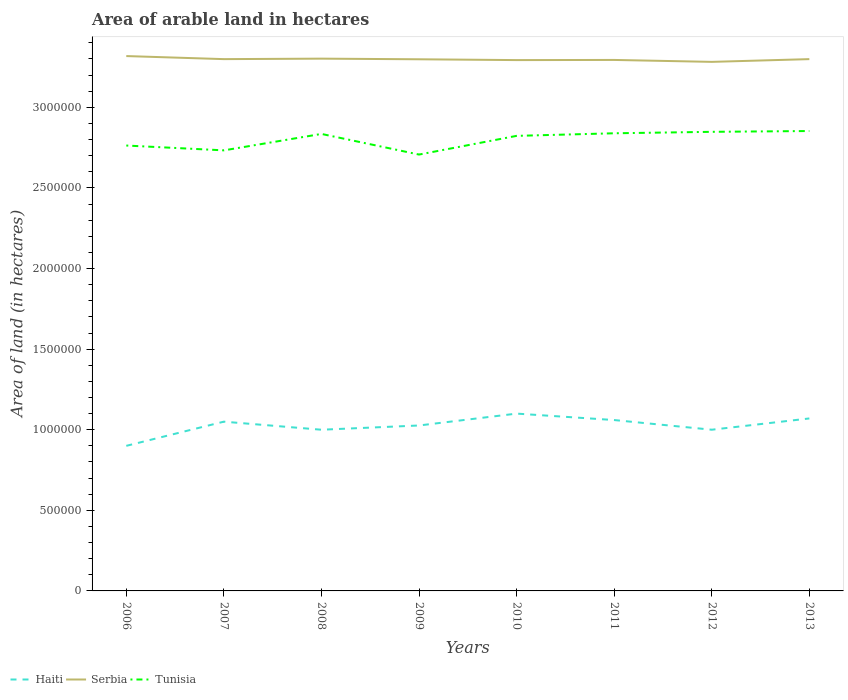Is the number of lines equal to the number of legend labels?
Offer a very short reply. Yes. Across all years, what is the maximum total arable land in Haiti?
Offer a very short reply. 9.00e+05. In which year was the total arable land in Haiti maximum?
Ensure brevity in your answer.  2006. What is the total total arable land in Serbia in the graph?
Keep it short and to the point. 1.10e+04. What is the difference between the highest and the second highest total arable land in Serbia?
Provide a succinct answer. 3.60e+04. Is the total arable land in Serbia strictly greater than the total arable land in Haiti over the years?
Make the answer very short. No. How many lines are there?
Give a very brief answer. 3. Are the values on the major ticks of Y-axis written in scientific E-notation?
Keep it short and to the point. No. Does the graph contain any zero values?
Your answer should be compact. No. How many legend labels are there?
Offer a terse response. 3. What is the title of the graph?
Your response must be concise. Area of arable land in hectares. What is the label or title of the Y-axis?
Offer a very short reply. Area of land (in hectares). What is the Area of land (in hectares) of Serbia in 2006?
Keep it short and to the point. 3.32e+06. What is the Area of land (in hectares) of Tunisia in 2006?
Provide a short and direct response. 2.76e+06. What is the Area of land (in hectares) of Haiti in 2007?
Ensure brevity in your answer.  1.05e+06. What is the Area of land (in hectares) of Serbia in 2007?
Give a very brief answer. 3.30e+06. What is the Area of land (in hectares) in Tunisia in 2007?
Ensure brevity in your answer.  2.73e+06. What is the Area of land (in hectares) in Serbia in 2008?
Keep it short and to the point. 3.30e+06. What is the Area of land (in hectares) in Tunisia in 2008?
Keep it short and to the point. 2.84e+06. What is the Area of land (in hectares) of Haiti in 2009?
Make the answer very short. 1.03e+06. What is the Area of land (in hectares) in Serbia in 2009?
Provide a succinct answer. 3.30e+06. What is the Area of land (in hectares) of Tunisia in 2009?
Your response must be concise. 2.71e+06. What is the Area of land (in hectares) in Haiti in 2010?
Keep it short and to the point. 1.10e+06. What is the Area of land (in hectares) in Serbia in 2010?
Your answer should be compact. 3.29e+06. What is the Area of land (in hectares) of Tunisia in 2010?
Ensure brevity in your answer.  2.82e+06. What is the Area of land (in hectares) in Haiti in 2011?
Offer a terse response. 1.06e+06. What is the Area of land (in hectares) in Serbia in 2011?
Your answer should be very brief. 3.29e+06. What is the Area of land (in hectares) in Tunisia in 2011?
Keep it short and to the point. 2.84e+06. What is the Area of land (in hectares) in Serbia in 2012?
Your answer should be compact. 3.28e+06. What is the Area of land (in hectares) of Tunisia in 2012?
Provide a succinct answer. 2.85e+06. What is the Area of land (in hectares) in Haiti in 2013?
Your response must be concise. 1.07e+06. What is the Area of land (in hectares) of Serbia in 2013?
Give a very brief answer. 3.30e+06. What is the Area of land (in hectares) in Tunisia in 2013?
Make the answer very short. 2.85e+06. Across all years, what is the maximum Area of land (in hectares) in Haiti?
Provide a short and direct response. 1.10e+06. Across all years, what is the maximum Area of land (in hectares) in Serbia?
Your answer should be very brief. 3.32e+06. Across all years, what is the maximum Area of land (in hectares) in Tunisia?
Offer a terse response. 2.85e+06. Across all years, what is the minimum Area of land (in hectares) in Haiti?
Your answer should be compact. 9.00e+05. Across all years, what is the minimum Area of land (in hectares) of Serbia?
Offer a terse response. 3.28e+06. Across all years, what is the minimum Area of land (in hectares) in Tunisia?
Provide a succinct answer. 2.71e+06. What is the total Area of land (in hectares) in Haiti in the graph?
Your response must be concise. 8.21e+06. What is the total Area of land (in hectares) of Serbia in the graph?
Provide a succinct answer. 2.64e+07. What is the total Area of land (in hectares) in Tunisia in the graph?
Ensure brevity in your answer.  2.24e+07. What is the difference between the Area of land (in hectares) of Haiti in 2006 and that in 2007?
Provide a short and direct response. -1.50e+05. What is the difference between the Area of land (in hectares) of Serbia in 2006 and that in 2007?
Your answer should be compact. 1.90e+04. What is the difference between the Area of land (in hectares) of Tunisia in 2006 and that in 2007?
Make the answer very short. 3.00e+04. What is the difference between the Area of land (in hectares) in Haiti in 2006 and that in 2008?
Keep it short and to the point. -1.00e+05. What is the difference between the Area of land (in hectares) of Serbia in 2006 and that in 2008?
Give a very brief answer. 1.60e+04. What is the difference between the Area of land (in hectares) of Tunisia in 2006 and that in 2008?
Provide a succinct answer. -7.20e+04. What is the difference between the Area of land (in hectares) of Haiti in 2006 and that in 2009?
Provide a succinct answer. -1.26e+05. What is the difference between the Area of land (in hectares) in Serbia in 2006 and that in 2009?
Offer a very short reply. 2.00e+04. What is the difference between the Area of land (in hectares) in Tunisia in 2006 and that in 2009?
Provide a short and direct response. 5.60e+04. What is the difference between the Area of land (in hectares) of Serbia in 2006 and that in 2010?
Offer a very short reply. 2.50e+04. What is the difference between the Area of land (in hectares) in Haiti in 2006 and that in 2011?
Provide a succinct answer. -1.60e+05. What is the difference between the Area of land (in hectares) in Serbia in 2006 and that in 2011?
Provide a succinct answer. 2.40e+04. What is the difference between the Area of land (in hectares) of Tunisia in 2006 and that in 2011?
Your response must be concise. -7.60e+04. What is the difference between the Area of land (in hectares) in Serbia in 2006 and that in 2012?
Your answer should be very brief. 3.60e+04. What is the difference between the Area of land (in hectares) in Tunisia in 2006 and that in 2012?
Your answer should be compact. -8.50e+04. What is the difference between the Area of land (in hectares) of Serbia in 2006 and that in 2013?
Make the answer very short. 1.90e+04. What is the difference between the Area of land (in hectares) in Haiti in 2007 and that in 2008?
Offer a very short reply. 5.00e+04. What is the difference between the Area of land (in hectares) of Serbia in 2007 and that in 2008?
Offer a very short reply. -3000. What is the difference between the Area of land (in hectares) in Tunisia in 2007 and that in 2008?
Give a very brief answer. -1.02e+05. What is the difference between the Area of land (in hectares) of Haiti in 2007 and that in 2009?
Offer a very short reply. 2.37e+04. What is the difference between the Area of land (in hectares) in Serbia in 2007 and that in 2009?
Your answer should be compact. 1000. What is the difference between the Area of land (in hectares) of Tunisia in 2007 and that in 2009?
Make the answer very short. 2.60e+04. What is the difference between the Area of land (in hectares) of Serbia in 2007 and that in 2010?
Keep it short and to the point. 6000. What is the difference between the Area of land (in hectares) of Haiti in 2007 and that in 2011?
Give a very brief answer. -10000. What is the difference between the Area of land (in hectares) in Tunisia in 2007 and that in 2011?
Your answer should be compact. -1.06e+05. What is the difference between the Area of land (in hectares) in Serbia in 2007 and that in 2012?
Give a very brief answer. 1.70e+04. What is the difference between the Area of land (in hectares) of Tunisia in 2007 and that in 2012?
Ensure brevity in your answer.  -1.15e+05. What is the difference between the Area of land (in hectares) of Serbia in 2007 and that in 2013?
Offer a terse response. 0. What is the difference between the Area of land (in hectares) in Haiti in 2008 and that in 2009?
Make the answer very short. -2.63e+04. What is the difference between the Area of land (in hectares) in Serbia in 2008 and that in 2009?
Offer a terse response. 4000. What is the difference between the Area of land (in hectares) in Tunisia in 2008 and that in 2009?
Your answer should be very brief. 1.28e+05. What is the difference between the Area of land (in hectares) of Serbia in 2008 and that in 2010?
Your answer should be compact. 9000. What is the difference between the Area of land (in hectares) in Tunisia in 2008 and that in 2010?
Offer a terse response. 1.20e+04. What is the difference between the Area of land (in hectares) in Serbia in 2008 and that in 2011?
Your answer should be very brief. 8000. What is the difference between the Area of land (in hectares) in Tunisia in 2008 and that in 2011?
Give a very brief answer. -4000. What is the difference between the Area of land (in hectares) of Tunisia in 2008 and that in 2012?
Offer a very short reply. -1.30e+04. What is the difference between the Area of land (in hectares) in Serbia in 2008 and that in 2013?
Offer a very short reply. 3000. What is the difference between the Area of land (in hectares) of Tunisia in 2008 and that in 2013?
Provide a short and direct response. -1.80e+04. What is the difference between the Area of land (in hectares) of Haiti in 2009 and that in 2010?
Offer a terse response. -7.37e+04. What is the difference between the Area of land (in hectares) in Tunisia in 2009 and that in 2010?
Make the answer very short. -1.16e+05. What is the difference between the Area of land (in hectares) in Haiti in 2009 and that in 2011?
Offer a very short reply. -3.37e+04. What is the difference between the Area of land (in hectares) in Serbia in 2009 and that in 2011?
Offer a terse response. 4000. What is the difference between the Area of land (in hectares) of Tunisia in 2009 and that in 2011?
Your answer should be very brief. -1.32e+05. What is the difference between the Area of land (in hectares) of Haiti in 2009 and that in 2012?
Make the answer very short. 2.63e+04. What is the difference between the Area of land (in hectares) in Serbia in 2009 and that in 2012?
Your response must be concise. 1.60e+04. What is the difference between the Area of land (in hectares) of Tunisia in 2009 and that in 2012?
Your answer should be very brief. -1.41e+05. What is the difference between the Area of land (in hectares) of Haiti in 2009 and that in 2013?
Ensure brevity in your answer.  -4.37e+04. What is the difference between the Area of land (in hectares) of Serbia in 2009 and that in 2013?
Provide a short and direct response. -1000. What is the difference between the Area of land (in hectares) in Tunisia in 2009 and that in 2013?
Keep it short and to the point. -1.46e+05. What is the difference between the Area of land (in hectares) of Haiti in 2010 and that in 2011?
Offer a terse response. 4.00e+04. What is the difference between the Area of land (in hectares) in Serbia in 2010 and that in 2011?
Keep it short and to the point. -1000. What is the difference between the Area of land (in hectares) of Tunisia in 2010 and that in 2011?
Your response must be concise. -1.60e+04. What is the difference between the Area of land (in hectares) in Serbia in 2010 and that in 2012?
Your answer should be compact. 1.10e+04. What is the difference between the Area of land (in hectares) of Tunisia in 2010 and that in 2012?
Keep it short and to the point. -2.50e+04. What is the difference between the Area of land (in hectares) in Haiti in 2010 and that in 2013?
Ensure brevity in your answer.  3.00e+04. What is the difference between the Area of land (in hectares) in Serbia in 2010 and that in 2013?
Offer a terse response. -6000. What is the difference between the Area of land (in hectares) of Tunisia in 2010 and that in 2013?
Your answer should be compact. -3.00e+04. What is the difference between the Area of land (in hectares) in Serbia in 2011 and that in 2012?
Provide a succinct answer. 1.20e+04. What is the difference between the Area of land (in hectares) in Tunisia in 2011 and that in 2012?
Offer a terse response. -9000. What is the difference between the Area of land (in hectares) of Haiti in 2011 and that in 2013?
Offer a terse response. -10000. What is the difference between the Area of land (in hectares) of Serbia in 2011 and that in 2013?
Offer a very short reply. -5000. What is the difference between the Area of land (in hectares) in Tunisia in 2011 and that in 2013?
Provide a short and direct response. -1.40e+04. What is the difference between the Area of land (in hectares) in Serbia in 2012 and that in 2013?
Offer a very short reply. -1.70e+04. What is the difference between the Area of land (in hectares) in Tunisia in 2012 and that in 2013?
Your response must be concise. -5000. What is the difference between the Area of land (in hectares) in Haiti in 2006 and the Area of land (in hectares) in Serbia in 2007?
Offer a terse response. -2.40e+06. What is the difference between the Area of land (in hectares) in Haiti in 2006 and the Area of land (in hectares) in Tunisia in 2007?
Give a very brief answer. -1.83e+06. What is the difference between the Area of land (in hectares) in Serbia in 2006 and the Area of land (in hectares) in Tunisia in 2007?
Ensure brevity in your answer.  5.85e+05. What is the difference between the Area of land (in hectares) of Haiti in 2006 and the Area of land (in hectares) of Serbia in 2008?
Give a very brief answer. -2.40e+06. What is the difference between the Area of land (in hectares) in Haiti in 2006 and the Area of land (in hectares) in Tunisia in 2008?
Your answer should be compact. -1.94e+06. What is the difference between the Area of land (in hectares) in Serbia in 2006 and the Area of land (in hectares) in Tunisia in 2008?
Provide a short and direct response. 4.83e+05. What is the difference between the Area of land (in hectares) of Haiti in 2006 and the Area of land (in hectares) of Serbia in 2009?
Offer a terse response. -2.40e+06. What is the difference between the Area of land (in hectares) in Haiti in 2006 and the Area of land (in hectares) in Tunisia in 2009?
Offer a terse response. -1.81e+06. What is the difference between the Area of land (in hectares) of Serbia in 2006 and the Area of land (in hectares) of Tunisia in 2009?
Your answer should be compact. 6.11e+05. What is the difference between the Area of land (in hectares) of Haiti in 2006 and the Area of land (in hectares) of Serbia in 2010?
Provide a short and direct response. -2.39e+06. What is the difference between the Area of land (in hectares) of Haiti in 2006 and the Area of land (in hectares) of Tunisia in 2010?
Your response must be concise. -1.92e+06. What is the difference between the Area of land (in hectares) in Serbia in 2006 and the Area of land (in hectares) in Tunisia in 2010?
Provide a succinct answer. 4.95e+05. What is the difference between the Area of land (in hectares) of Haiti in 2006 and the Area of land (in hectares) of Serbia in 2011?
Your response must be concise. -2.39e+06. What is the difference between the Area of land (in hectares) of Haiti in 2006 and the Area of land (in hectares) of Tunisia in 2011?
Offer a very short reply. -1.94e+06. What is the difference between the Area of land (in hectares) of Serbia in 2006 and the Area of land (in hectares) of Tunisia in 2011?
Your answer should be very brief. 4.79e+05. What is the difference between the Area of land (in hectares) of Haiti in 2006 and the Area of land (in hectares) of Serbia in 2012?
Offer a very short reply. -2.38e+06. What is the difference between the Area of land (in hectares) of Haiti in 2006 and the Area of land (in hectares) of Tunisia in 2012?
Keep it short and to the point. -1.95e+06. What is the difference between the Area of land (in hectares) in Haiti in 2006 and the Area of land (in hectares) in Serbia in 2013?
Your response must be concise. -2.40e+06. What is the difference between the Area of land (in hectares) in Haiti in 2006 and the Area of land (in hectares) in Tunisia in 2013?
Ensure brevity in your answer.  -1.95e+06. What is the difference between the Area of land (in hectares) of Serbia in 2006 and the Area of land (in hectares) of Tunisia in 2013?
Keep it short and to the point. 4.65e+05. What is the difference between the Area of land (in hectares) of Haiti in 2007 and the Area of land (in hectares) of Serbia in 2008?
Your response must be concise. -2.25e+06. What is the difference between the Area of land (in hectares) of Haiti in 2007 and the Area of land (in hectares) of Tunisia in 2008?
Keep it short and to the point. -1.78e+06. What is the difference between the Area of land (in hectares) in Serbia in 2007 and the Area of land (in hectares) in Tunisia in 2008?
Give a very brief answer. 4.64e+05. What is the difference between the Area of land (in hectares) of Haiti in 2007 and the Area of land (in hectares) of Serbia in 2009?
Ensure brevity in your answer.  -2.25e+06. What is the difference between the Area of land (in hectares) of Haiti in 2007 and the Area of land (in hectares) of Tunisia in 2009?
Offer a very short reply. -1.66e+06. What is the difference between the Area of land (in hectares) in Serbia in 2007 and the Area of land (in hectares) in Tunisia in 2009?
Your response must be concise. 5.92e+05. What is the difference between the Area of land (in hectares) of Haiti in 2007 and the Area of land (in hectares) of Serbia in 2010?
Your response must be concise. -2.24e+06. What is the difference between the Area of land (in hectares) in Haiti in 2007 and the Area of land (in hectares) in Tunisia in 2010?
Give a very brief answer. -1.77e+06. What is the difference between the Area of land (in hectares) of Serbia in 2007 and the Area of land (in hectares) of Tunisia in 2010?
Provide a succinct answer. 4.76e+05. What is the difference between the Area of land (in hectares) in Haiti in 2007 and the Area of land (in hectares) in Serbia in 2011?
Offer a very short reply. -2.24e+06. What is the difference between the Area of land (in hectares) of Haiti in 2007 and the Area of land (in hectares) of Tunisia in 2011?
Offer a very short reply. -1.79e+06. What is the difference between the Area of land (in hectares) of Serbia in 2007 and the Area of land (in hectares) of Tunisia in 2011?
Keep it short and to the point. 4.60e+05. What is the difference between the Area of land (in hectares) of Haiti in 2007 and the Area of land (in hectares) of Serbia in 2012?
Give a very brief answer. -2.23e+06. What is the difference between the Area of land (in hectares) of Haiti in 2007 and the Area of land (in hectares) of Tunisia in 2012?
Offer a very short reply. -1.80e+06. What is the difference between the Area of land (in hectares) in Serbia in 2007 and the Area of land (in hectares) in Tunisia in 2012?
Offer a very short reply. 4.51e+05. What is the difference between the Area of land (in hectares) in Haiti in 2007 and the Area of land (in hectares) in Serbia in 2013?
Make the answer very short. -2.25e+06. What is the difference between the Area of land (in hectares) in Haiti in 2007 and the Area of land (in hectares) in Tunisia in 2013?
Offer a very short reply. -1.80e+06. What is the difference between the Area of land (in hectares) of Serbia in 2007 and the Area of land (in hectares) of Tunisia in 2013?
Give a very brief answer. 4.46e+05. What is the difference between the Area of land (in hectares) in Haiti in 2008 and the Area of land (in hectares) in Serbia in 2009?
Your answer should be compact. -2.30e+06. What is the difference between the Area of land (in hectares) of Haiti in 2008 and the Area of land (in hectares) of Tunisia in 2009?
Offer a very short reply. -1.71e+06. What is the difference between the Area of land (in hectares) of Serbia in 2008 and the Area of land (in hectares) of Tunisia in 2009?
Your response must be concise. 5.95e+05. What is the difference between the Area of land (in hectares) of Haiti in 2008 and the Area of land (in hectares) of Serbia in 2010?
Offer a very short reply. -2.29e+06. What is the difference between the Area of land (in hectares) in Haiti in 2008 and the Area of land (in hectares) in Tunisia in 2010?
Make the answer very short. -1.82e+06. What is the difference between the Area of land (in hectares) of Serbia in 2008 and the Area of land (in hectares) of Tunisia in 2010?
Offer a terse response. 4.79e+05. What is the difference between the Area of land (in hectares) of Haiti in 2008 and the Area of land (in hectares) of Serbia in 2011?
Provide a short and direct response. -2.29e+06. What is the difference between the Area of land (in hectares) of Haiti in 2008 and the Area of land (in hectares) of Tunisia in 2011?
Provide a short and direct response. -1.84e+06. What is the difference between the Area of land (in hectares) in Serbia in 2008 and the Area of land (in hectares) in Tunisia in 2011?
Offer a very short reply. 4.63e+05. What is the difference between the Area of land (in hectares) in Haiti in 2008 and the Area of land (in hectares) in Serbia in 2012?
Ensure brevity in your answer.  -2.28e+06. What is the difference between the Area of land (in hectares) in Haiti in 2008 and the Area of land (in hectares) in Tunisia in 2012?
Your answer should be compact. -1.85e+06. What is the difference between the Area of land (in hectares) of Serbia in 2008 and the Area of land (in hectares) of Tunisia in 2012?
Your response must be concise. 4.54e+05. What is the difference between the Area of land (in hectares) of Haiti in 2008 and the Area of land (in hectares) of Serbia in 2013?
Your answer should be compact. -2.30e+06. What is the difference between the Area of land (in hectares) in Haiti in 2008 and the Area of land (in hectares) in Tunisia in 2013?
Ensure brevity in your answer.  -1.85e+06. What is the difference between the Area of land (in hectares) of Serbia in 2008 and the Area of land (in hectares) of Tunisia in 2013?
Provide a succinct answer. 4.49e+05. What is the difference between the Area of land (in hectares) in Haiti in 2009 and the Area of land (in hectares) in Serbia in 2010?
Give a very brief answer. -2.27e+06. What is the difference between the Area of land (in hectares) of Haiti in 2009 and the Area of land (in hectares) of Tunisia in 2010?
Make the answer very short. -1.80e+06. What is the difference between the Area of land (in hectares) in Serbia in 2009 and the Area of land (in hectares) in Tunisia in 2010?
Give a very brief answer. 4.75e+05. What is the difference between the Area of land (in hectares) of Haiti in 2009 and the Area of land (in hectares) of Serbia in 2011?
Give a very brief answer. -2.27e+06. What is the difference between the Area of land (in hectares) of Haiti in 2009 and the Area of land (in hectares) of Tunisia in 2011?
Offer a terse response. -1.81e+06. What is the difference between the Area of land (in hectares) in Serbia in 2009 and the Area of land (in hectares) in Tunisia in 2011?
Ensure brevity in your answer.  4.59e+05. What is the difference between the Area of land (in hectares) in Haiti in 2009 and the Area of land (in hectares) in Serbia in 2012?
Make the answer very short. -2.26e+06. What is the difference between the Area of land (in hectares) in Haiti in 2009 and the Area of land (in hectares) in Tunisia in 2012?
Ensure brevity in your answer.  -1.82e+06. What is the difference between the Area of land (in hectares) of Haiti in 2009 and the Area of land (in hectares) of Serbia in 2013?
Provide a short and direct response. -2.27e+06. What is the difference between the Area of land (in hectares) of Haiti in 2009 and the Area of land (in hectares) of Tunisia in 2013?
Provide a succinct answer. -1.83e+06. What is the difference between the Area of land (in hectares) of Serbia in 2009 and the Area of land (in hectares) of Tunisia in 2013?
Your answer should be compact. 4.45e+05. What is the difference between the Area of land (in hectares) in Haiti in 2010 and the Area of land (in hectares) in Serbia in 2011?
Your response must be concise. -2.19e+06. What is the difference between the Area of land (in hectares) of Haiti in 2010 and the Area of land (in hectares) of Tunisia in 2011?
Offer a terse response. -1.74e+06. What is the difference between the Area of land (in hectares) of Serbia in 2010 and the Area of land (in hectares) of Tunisia in 2011?
Provide a short and direct response. 4.54e+05. What is the difference between the Area of land (in hectares) in Haiti in 2010 and the Area of land (in hectares) in Serbia in 2012?
Provide a short and direct response. -2.18e+06. What is the difference between the Area of land (in hectares) in Haiti in 2010 and the Area of land (in hectares) in Tunisia in 2012?
Provide a short and direct response. -1.75e+06. What is the difference between the Area of land (in hectares) in Serbia in 2010 and the Area of land (in hectares) in Tunisia in 2012?
Give a very brief answer. 4.45e+05. What is the difference between the Area of land (in hectares) of Haiti in 2010 and the Area of land (in hectares) of Serbia in 2013?
Your response must be concise. -2.20e+06. What is the difference between the Area of land (in hectares) in Haiti in 2010 and the Area of land (in hectares) in Tunisia in 2013?
Provide a short and direct response. -1.75e+06. What is the difference between the Area of land (in hectares) of Serbia in 2010 and the Area of land (in hectares) of Tunisia in 2013?
Offer a terse response. 4.40e+05. What is the difference between the Area of land (in hectares) of Haiti in 2011 and the Area of land (in hectares) of Serbia in 2012?
Provide a succinct answer. -2.22e+06. What is the difference between the Area of land (in hectares) in Haiti in 2011 and the Area of land (in hectares) in Tunisia in 2012?
Offer a very short reply. -1.79e+06. What is the difference between the Area of land (in hectares) of Serbia in 2011 and the Area of land (in hectares) of Tunisia in 2012?
Provide a short and direct response. 4.46e+05. What is the difference between the Area of land (in hectares) of Haiti in 2011 and the Area of land (in hectares) of Serbia in 2013?
Offer a very short reply. -2.24e+06. What is the difference between the Area of land (in hectares) in Haiti in 2011 and the Area of land (in hectares) in Tunisia in 2013?
Make the answer very short. -1.79e+06. What is the difference between the Area of land (in hectares) of Serbia in 2011 and the Area of land (in hectares) of Tunisia in 2013?
Give a very brief answer. 4.41e+05. What is the difference between the Area of land (in hectares) of Haiti in 2012 and the Area of land (in hectares) of Serbia in 2013?
Offer a very short reply. -2.30e+06. What is the difference between the Area of land (in hectares) in Haiti in 2012 and the Area of land (in hectares) in Tunisia in 2013?
Offer a very short reply. -1.85e+06. What is the difference between the Area of land (in hectares) of Serbia in 2012 and the Area of land (in hectares) of Tunisia in 2013?
Provide a succinct answer. 4.29e+05. What is the average Area of land (in hectares) of Haiti per year?
Your answer should be compact. 1.03e+06. What is the average Area of land (in hectares) of Serbia per year?
Give a very brief answer. 3.30e+06. What is the average Area of land (in hectares) in Tunisia per year?
Give a very brief answer. 2.80e+06. In the year 2006, what is the difference between the Area of land (in hectares) of Haiti and Area of land (in hectares) of Serbia?
Make the answer very short. -2.42e+06. In the year 2006, what is the difference between the Area of land (in hectares) of Haiti and Area of land (in hectares) of Tunisia?
Provide a short and direct response. -1.86e+06. In the year 2006, what is the difference between the Area of land (in hectares) of Serbia and Area of land (in hectares) of Tunisia?
Give a very brief answer. 5.55e+05. In the year 2007, what is the difference between the Area of land (in hectares) in Haiti and Area of land (in hectares) in Serbia?
Ensure brevity in your answer.  -2.25e+06. In the year 2007, what is the difference between the Area of land (in hectares) of Haiti and Area of land (in hectares) of Tunisia?
Offer a very short reply. -1.68e+06. In the year 2007, what is the difference between the Area of land (in hectares) of Serbia and Area of land (in hectares) of Tunisia?
Offer a terse response. 5.66e+05. In the year 2008, what is the difference between the Area of land (in hectares) of Haiti and Area of land (in hectares) of Serbia?
Make the answer very short. -2.30e+06. In the year 2008, what is the difference between the Area of land (in hectares) of Haiti and Area of land (in hectares) of Tunisia?
Ensure brevity in your answer.  -1.84e+06. In the year 2008, what is the difference between the Area of land (in hectares) of Serbia and Area of land (in hectares) of Tunisia?
Offer a terse response. 4.67e+05. In the year 2009, what is the difference between the Area of land (in hectares) in Haiti and Area of land (in hectares) in Serbia?
Your answer should be compact. -2.27e+06. In the year 2009, what is the difference between the Area of land (in hectares) of Haiti and Area of land (in hectares) of Tunisia?
Offer a terse response. -1.68e+06. In the year 2009, what is the difference between the Area of land (in hectares) in Serbia and Area of land (in hectares) in Tunisia?
Your answer should be very brief. 5.91e+05. In the year 2010, what is the difference between the Area of land (in hectares) in Haiti and Area of land (in hectares) in Serbia?
Your response must be concise. -2.19e+06. In the year 2010, what is the difference between the Area of land (in hectares) of Haiti and Area of land (in hectares) of Tunisia?
Offer a terse response. -1.72e+06. In the year 2011, what is the difference between the Area of land (in hectares) in Haiti and Area of land (in hectares) in Serbia?
Your answer should be compact. -2.23e+06. In the year 2011, what is the difference between the Area of land (in hectares) of Haiti and Area of land (in hectares) of Tunisia?
Offer a very short reply. -1.78e+06. In the year 2011, what is the difference between the Area of land (in hectares) in Serbia and Area of land (in hectares) in Tunisia?
Offer a very short reply. 4.55e+05. In the year 2012, what is the difference between the Area of land (in hectares) of Haiti and Area of land (in hectares) of Serbia?
Ensure brevity in your answer.  -2.28e+06. In the year 2012, what is the difference between the Area of land (in hectares) of Haiti and Area of land (in hectares) of Tunisia?
Provide a succinct answer. -1.85e+06. In the year 2012, what is the difference between the Area of land (in hectares) in Serbia and Area of land (in hectares) in Tunisia?
Provide a succinct answer. 4.34e+05. In the year 2013, what is the difference between the Area of land (in hectares) in Haiti and Area of land (in hectares) in Serbia?
Your answer should be compact. -2.23e+06. In the year 2013, what is the difference between the Area of land (in hectares) in Haiti and Area of land (in hectares) in Tunisia?
Your answer should be very brief. -1.78e+06. In the year 2013, what is the difference between the Area of land (in hectares) in Serbia and Area of land (in hectares) in Tunisia?
Give a very brief answer. 4.46e+05. What is the ratio of the Area of land (in hectares) of Haiti in 2006 to that in 2007?
Ensure brevity in your answer.  0.86. What is the ratio of the Area of land (in hectares) of Tunisia in 2006 to that in 2007?
Make the answer very short. 1.01. What is the ratio of the Area of land (in hectares) in Haiti in 2006 to that in 2008?
Give a very brief answer. 0.9. What is the ratio of the Area of land (in hectares) of Tunisia in 2006 to that in 2008?
Your answer should be compact. 0.97. What is the ratio of the Area of land (in hectares) in Haiti in 2006 to that in 2009?
Make the answer very short. 0.88. What is the ratio of the Area of land (in hectares) in Serbia in 2006 to that in 2009?
Offer a very short reply. 1.01. What is the ratio of the Area of land (in hectares) in Tunisia in 2006 to that in 2009?
Give a very brief answer. 1.02. What is the ratio of the Area of land (in hectares) of Haiti in 2006 to that in 2010?
Your response must be concise. 0.82. What is the ratio of the Area of land (in hectares) in Serbia in 2006 to that in 2010?
Keep it short and to the point. 1.01. What is the ratio of the Area of land (in hectares) of Tunisia in 2006 to that in 2010?
Offer a very short reply. 0.98. What is the ratio of the Area of land (in hectares) in Haiti in 2006 to that in 2011?
Offer a terse response. 0.85. What is the ratio of the Area of land (in hectares) in Serbia in 2006 to that in 2011?
Offer a very short reply. 1.01. What is the ratio of the Area of land (in hectares) of Tunisia in 2006 to that in 2011?
Provide a short and direct response. 0.97. What is the ratio of the Area of land (in hectares) in Haiti in 2006 to that in 2012?
Make the answer very short. 0.9. What is the ratio of the Area of land (in hectares) in Tunisia in 2006 to that in 2012?
Give a very brief answer. 0.97. What is the ratio of the Area of land (in hectares) in Haiti in 2006 to that in 2013?
Keep it short and to the point. 0.84. What is the ratio of the Area of land (in hectares) of Serbia in 2006 to that in 2013?
Keep it short and to the point. 1.01. What is the ratio of the Area of land (in hectares) in Tunisia in 2006 to that in 2013?
Keep it short and to the point. 0.97. What is the ratio of the Area of land (in hectares) of Haiti in 2007 to that in 2008?
Offer a very short reply. 1.05. What is the ratio of the Area of land (in hectares) in Tunisia in 2007 to that in 2008?
Offer a terse response. 0.96. What is the ratio of the Area of land (in hectares) of Haiti in 2007 to that in 2009?
Your answer should be compact. 1.02. What is the ratio of the Area of land (in hectares) in Tunisia in 2007 to that in 2009?
Your response must be concise. 1.01. What is the ratio of the Area of land (in hectares) in Haiti in 2007 to that in 2010?
Offer a very short reply. 0.95. What is the ratio of the Area of land (in hectares) of Serbia in 2007 to that in 2010?
Your answer should be very brief. 1. What is the ratio of the Area of land (in hectares) of Tunisia in 2007 to that in 2010?
Your answer should be compact. 0.97. What is the ratio of the Area of land (in hectares) in Haiti in 2007 to that in 2011?
Provide a short and direct response. 0.99. What is the ratio of the Area of land (in hectares) of Serbia in 2007 to that in 2011?
Provide a succinct answer. 1. What is the ratio of the Area of land (in hectares) of Tunisia in 2007 to that in 2011?
Your answer should be compact. 0.96. What is the ratio of the Area of land (in hectares) in Serbia in 2007 to that in 2012?
Offer a terse response. 1.01. What is the ratio of the Area of land (in hectares) of Tunisia in 2007 to that in 2012?
Ensure brevity in your answer.  0.96. What is the ratio of the Area of land (in hectares) of Haiti in 2007 to that in 2013?
Keep it short and to the point. 0.98. What is the ratio of the Area of land (in hectares) in Tunisia in 2007 to that in 2013?
Your answer should be compact. 0.96. What is the ratio of the Area of land (in hectares) of Haiti in 2008 to that in 2009?
Keep it short and to the point. 0.97. What is the ratio of the Area of land (in hectares) in Serbia in 2008 to that in 2009?
Provide a succinct answer. 1. What is the ratio of the Area of land (in hectares) of Tunisia in 2008 to that in 2009?
Your response must be concise. 1.05. What is the ratio of the Area of land (in hectares) of Haiti in 2008 to that in 2011?
Make the answer very short. 0.94. What is the ratio of the Area of land (in hectares) in Serbia in 2008 to that in 2011?
Make the answer very short. 1. What is the ratio of the Area of land (in hectares) of Serbia in 2008 to that in 2012?
Your response must be concise. 1.01. What is the ratio of the Area of land (in hectares) in Tunisia in 2008 to that in 2012?
Keep it short and to the point. 1. What is the ratio of the Area of land (in hectares) in Haiti in 2008 to that in 2013?
Ensure brevity in your answer.  0.93. What is the ratio of the Area of land (in hectares) in Serbia in 2008 to that in 2013?
Offer a terse response. 1. What is the ratio of the Area of land (in hectares) of Haiti in 2009 to that in 2010?
Your answer should be compact. 0.93. What is the ratio of the Area of land (in hectares) of Tunisia in 2009 to that in 2010?
Give a very brief answer. 0.96. What is the ratio of the Area of land (in hectares) in Haiti in 2009 to that in 2011?
Make the answer very short. 0.97. What is the ratio of the Area of land (in hectares) of Tunisia in 2009 to that in 2011?
Provide a succinct answer. 0.95. What is the ratio of the Area of land (in hectares) in Haiti in 2009 to that in 2012?
Give a very brief answer. 1.03. What is the ratio of the Area of land (in hectares) of Serbia in 2009 to that in 2012?
Give a very brief answer. 1. What is the ratio of the Area of land (in hectares) of Tunisia in 2009 to that in 2012?
Your response must be concise. 0.95. What is the ratio of the Area of land (in hectares) in Haiti in 2009 to that in 2013?
Ensure brevity in your answer.  0.96. What is the ratio of the Area of land (in hectares) of Tunisia in 2009 to that in 2013?
Provide a succinct answer. 0.95. What is the ratio of the Area of land (in hectares) in Haiti in 2010 to that in 2011?
Your response must be concise. 1.04. What is the ratio of the Area of land (in hectares) of Serbia in 2010 to that in 2011?
Ensure brevity in your answer.  1. What is the ratio of the Area of land (in hectares) of Serbia in 2010 to that in 2012?
Offer a terse response. 1. What is the ratio of the Area of land (in hectares) of Haiti in 2010 to that in 2013?
Offer a terse response. 1.03. What is the ratio of the Area of land (in hectares) in Tunisia in 2010 to that in 2013?
Keep it short and to the point. 0.99. What is the ratio of the Area of land (in hectares) in Haiti in 2011 to that in 2012?
Provide a succinct answer. 1.06. What is the ratio of the Area of land (in hectares) in Tunisia in 2011 to that in 2013?
Provide a short and direct response. 1. What is the ratio of the Area of land (in hectares) in Haiti in 2012 to that in 2013?
Offer a terse response. 0.93. What is the ratio of the Area of land (in hectares) of Tunisia in 2012 to that in 2013?
Give a very brief answer. 1. What is the difference between the highest and the second highest Area of land (in hectares) of Serbia?
Ensure brevity in your answer.  1.60e+04. What is the difference between the highest and the second highest Area of land (in hectares) of Tunisia?
Your answer should be compact. 5000. What is the difference between the highest and the lowest Area of land (in hectares) of Haiti?
Give a very brief answer. 2.00e+05. What is the difference between the highest and the lowest Area of land (in hectares) in Serbia?
Offer a terse response. 3.60e+04. What is the difference between the highest and the lowest Area of land (in hectares) of Tunisia?
Keep it short and to the point. 1.46e+05. 